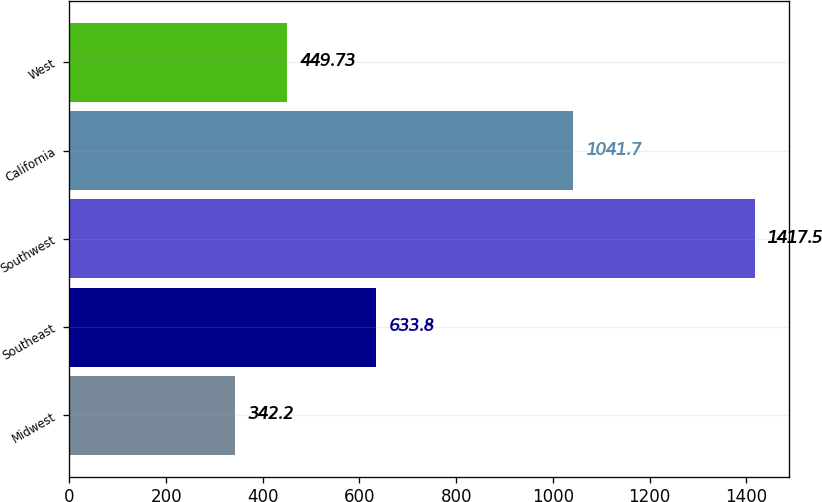<chart> <loc_0><loc_0><loc_500><loc_500><bar_chart><fcel>Midwest<fcel>Southeast<fcel>Southwest<fcel>California<fcel>West<nl><fcel>342.2<fcel>633.8<fcel>1417.5<fcel>1041.7<fcel>449.73<nl></chart> 